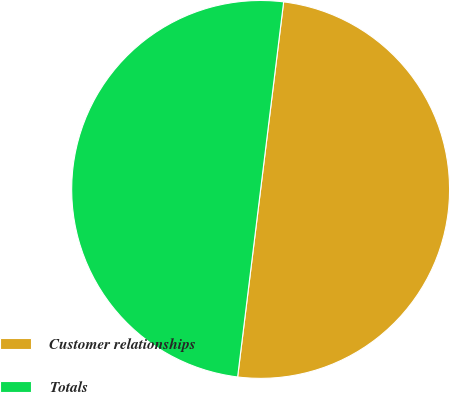Convert chart to OTSL. <chart><loc_0><loc_0><loc_500><loc_500><pie_chart><fcel>Customer relationships<fcel>Totals<nl><fcel>50.0%<fcel>50.0%<nl></chart> 